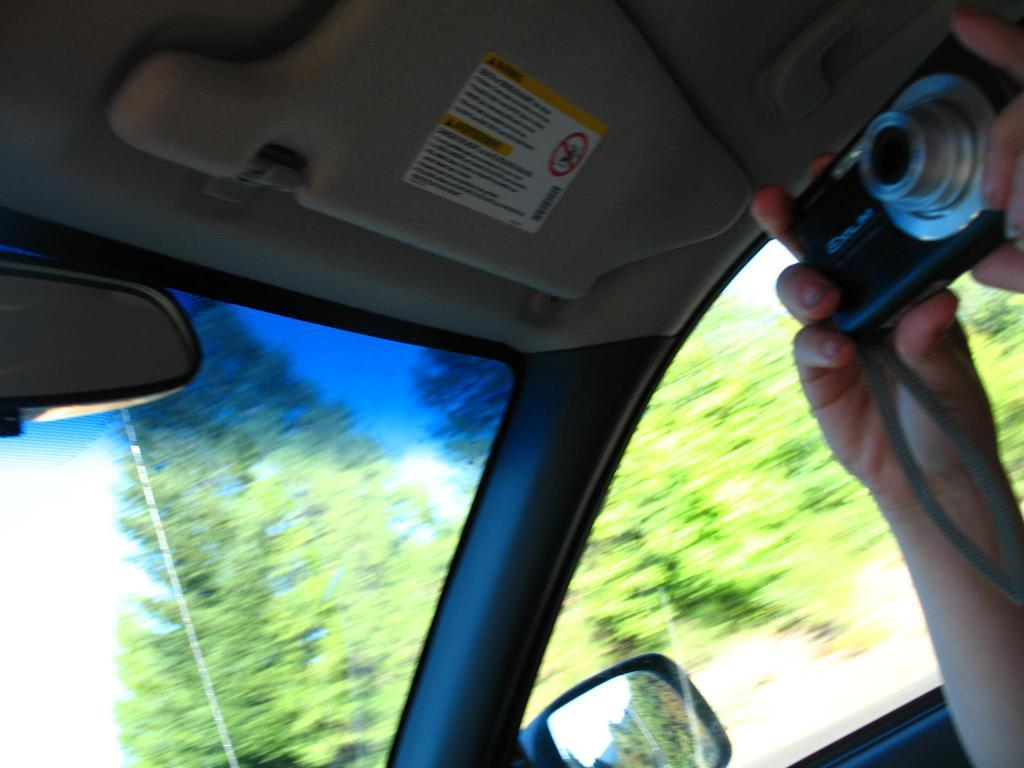What is the perspective of the image? The image is taken from a car. Who is taking the picture in the image? A person is holding a camera in the image. What type of natural scenery can be seen in the image? There are trees visible in the image. What type of humor can be seen in the image? There is no humor present in the image; it is a photograph taken from a car with a person holding a camera and trees visible in the background. Can you hear the person in the image coughing? There is no sound in the image, so it is impossible to determine if the person is coughing or not. 